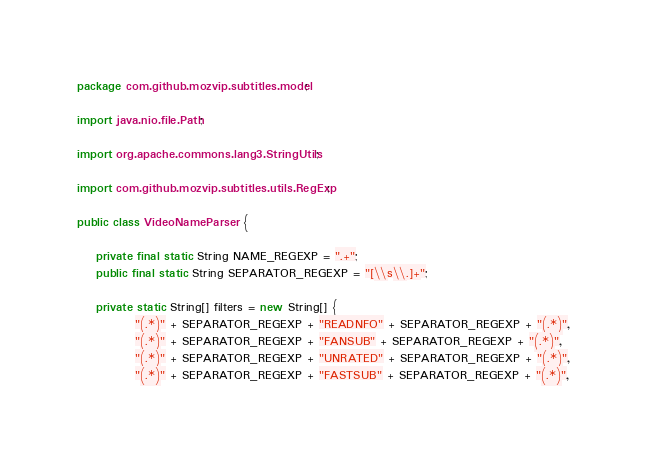Convert code to text. <code><loc_0><loc_0><loc_500><loc_500><_Java_>package com.github.mozvip.subtitles.model;

import java.nio.file.Path;

import org.apache.commons.lang3.StringUtils;

import com.github.mozvip.subtitles.utils.RegExp;

public class VideoNameParser {

	private final static String NAME_REGEXP = ".+";
	public final static String SEPARATOR_REGEXP = "[\\s\\.]+";
	
	private static String[] filters = new String[] {
			"(.*)" + SEPARATOR_REGEXP + "READNFO" + SEPARATOR_REGEXP + "(.*)",
			"(.*)" + SEPARATOR_REGEXP + "FANSUB" + SEPARATOR_REGEXP + "(.*)",
			"(.*)" + SEPARATOR_REGEXP + "UNRATED" + SEPARATOR_REGEXP + "(.*)",
			"(.*)" + SEPARATOR_REGEXP + "FASTSUB" + SEPARATOR_REGEXP + "(.*)",</code> 